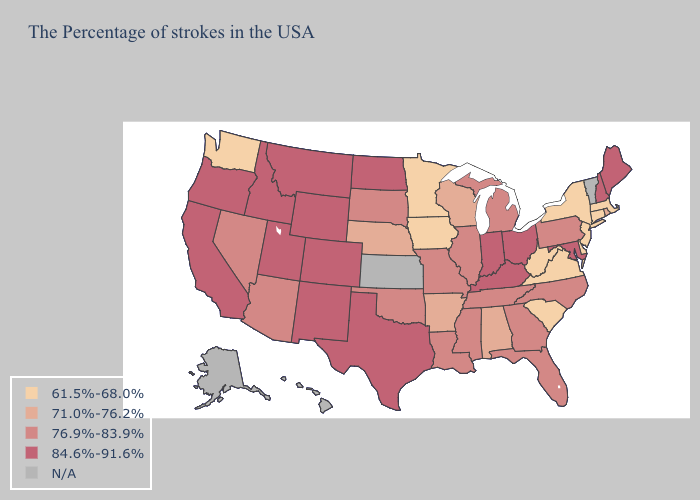What is the value of Kentucky?
Keep it brief. 84.6%-91.6%. Does Massachusetts have the highest value in the USA?
Concise answer only. No. Name the states that have a value in the range 76.9%-83.9%?
Be succinct. Pennsylvania, North Carolina, Florida, Georgia, Michigan, Tennessee, Illinois, Mississippi, Louisiana, Missouri, Oklahoma, South Dakota, Arizona, Nevada. What is the value of Nevada?
Concise answer only. 76.9%-83.9%. What is the highest value in states that border California?
Write a very short answer. 84.6%-91.6%. Which states have the lowest value in the Northeast?
Short answer required. Massachusetts, Connecticut, New York, New Jersey. What is the highest value in the USA?
Answer briefly. 84.6%-91.6%. Does the map have missing data?
Concise answer only. Yes. Name the states that have a value in the range 84.6%-91.6%?
Write a very short answer. Maine, New Hampshire, Maryland, Ohio, Kentucky, Indiana, Texas, North Dakota, Wyoming, Colorado, New Mexico, Utah, Montana, Idaho, California, Oregon. What is the highest value in the South ?
Answer briefly. 84.6%-91.6%. Does Wyoming have the lowest value in the USA?
Quick response, please. No. What is the value of Colorado?
Short answer required. 84.6%-91.6%. 